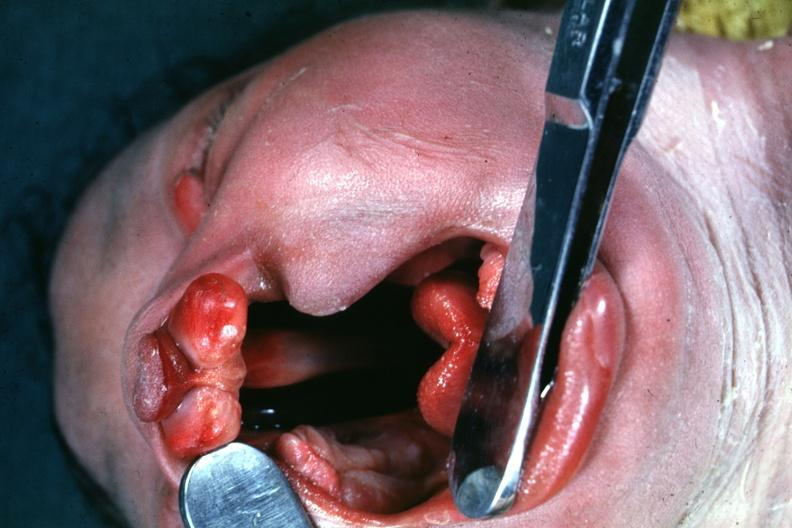what opened to show large defect very good illustration of this lesion?
Answer the question using a single word or phrase. Head tilted with mouth 